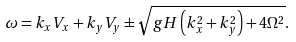Convert formula to latex. <formula><loc_0><loc_0><loc_500><loc_500>\omega = k _ { x } V _ { x } + k _ { y } V _ { y } \pm \sqrt { g H \left ( k ^ { 2 } _ { x } + k ^ { 2 } _ { y } \right ) + 4 \Omega ^ { 2 } } .</formula> 